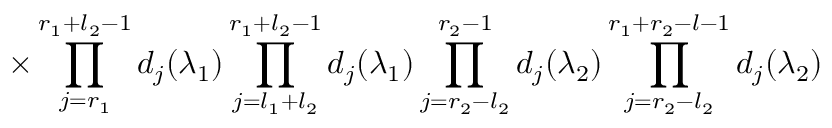Convert formula to latex. <formula><loc_0><loc_0><loc_500><loc_500>\times \prod _ { j = r _ { 1 } } ^ { r _ { 1 } + l _ { 2 } - 1 } d _ { j } ( \lambda _ { 1 } ) \prod _ { j = l _ { 1 } + l _ { 2 } } ^ { r _ { 1 } + l _ { 2 } - 1 } d _ { j } ( \lambda _ { 1 } ) \prod _ { j = r _ { 2 } - l _ { 2 } } ^ { r _ { 2 } - 1 } d _ { j } ( \lambda _ { 2 } ) \prod _ { j = r _ { 2 } - l _ { 2 } } ^ { r _ { 1 } + r _ { 2 } - l - 1 } d _ { j } ( \lambda _ { 2 } )</formula> 